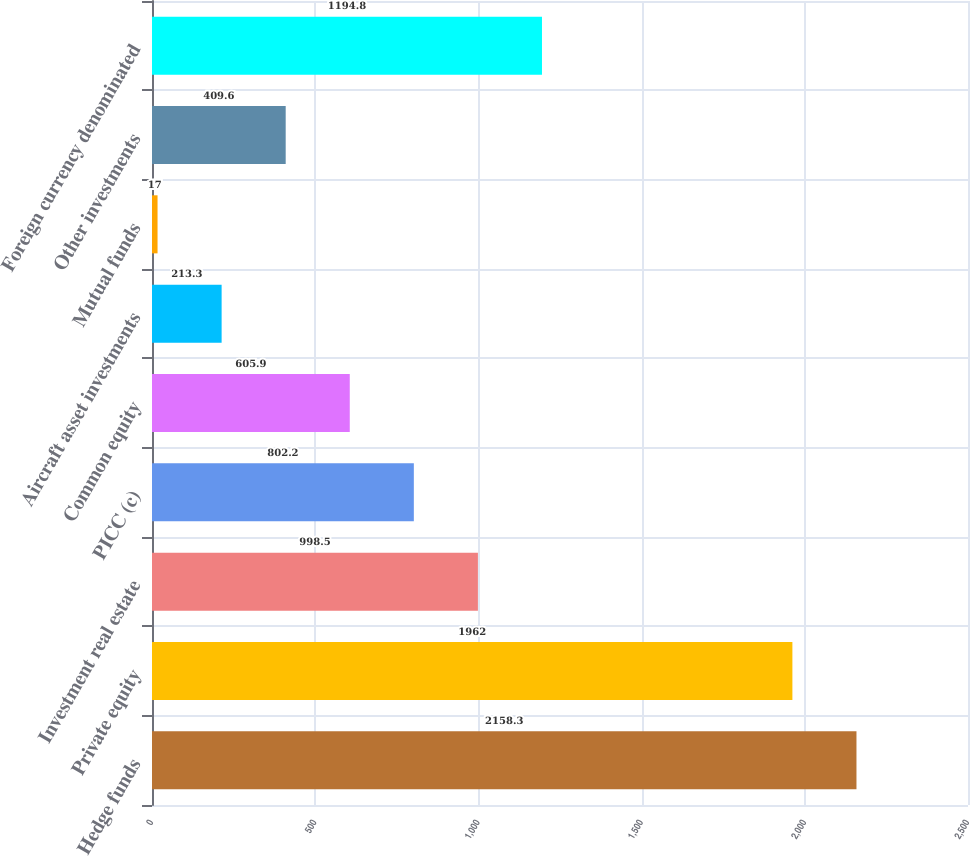Convert chart to OTSL. <chart><loc_0><loc_0><loc_500><loc_500><bar_chart><fcel>Hedge funds<fcel>Private equity<fcel>Investment real estate<fcel>PICC (c)<fcel>Common equity<fcel>Aircraft asset investments<fcel>Mutual funds<fcel>Other investments<fcel>Foreign currency denominated<nl><fcel>2158.3<fcel>1962<fcel>998.5<fcel>802.2<fcel>605.9<fcel>213.3<fcel>17<fcel>409.6<fcel>1194.8<nl></chart> 